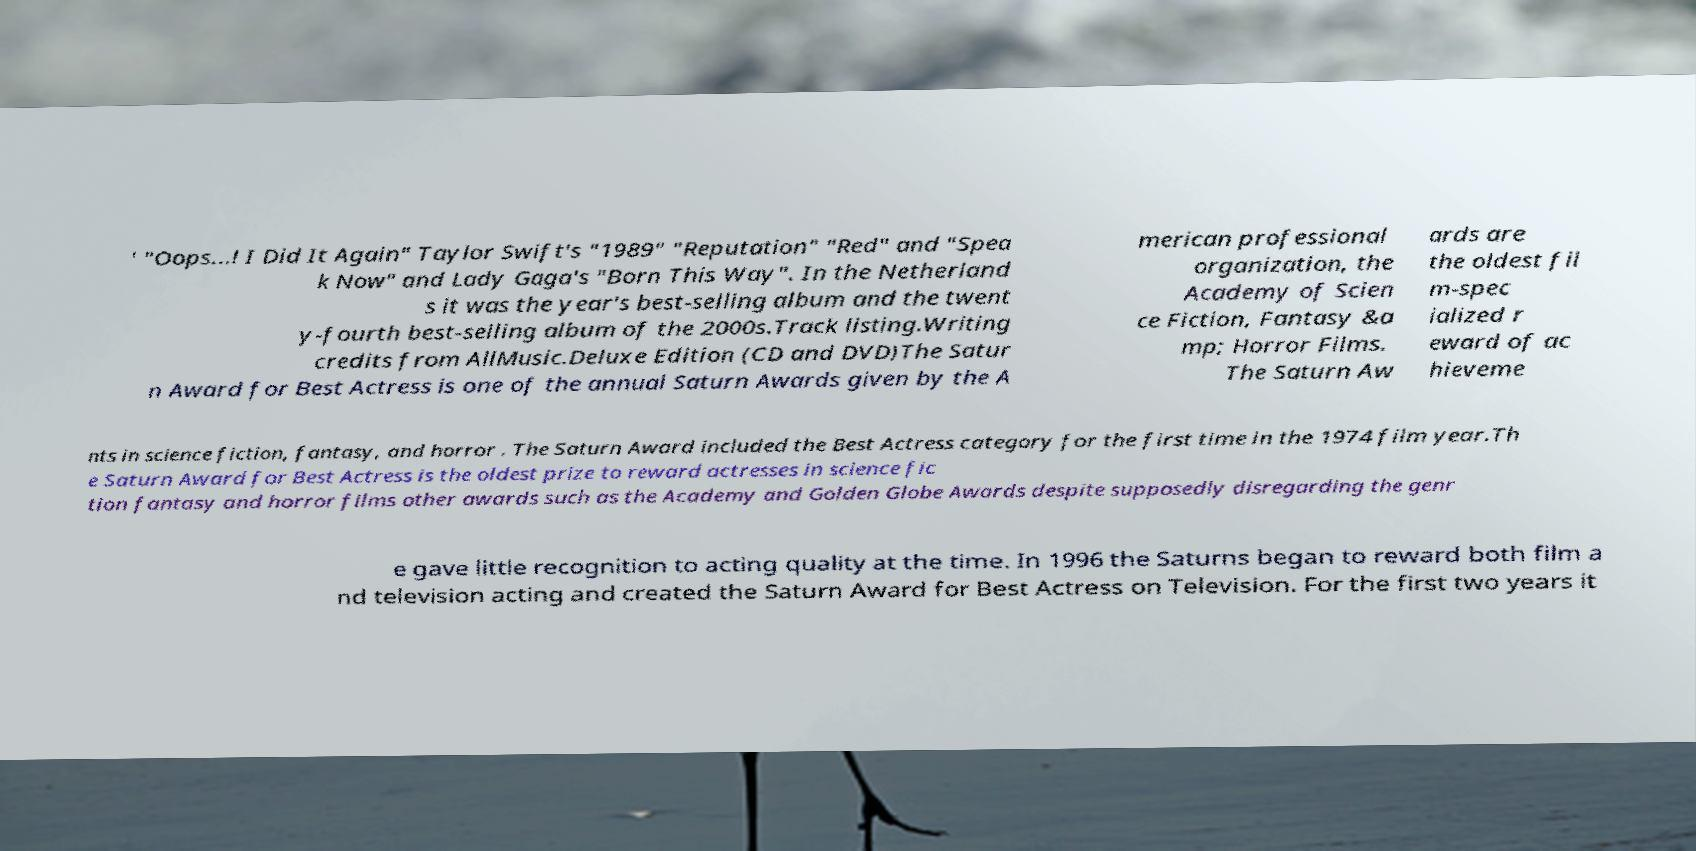For documentation purposes, I need the text within this image transcribed. Could you provide that? ' "Oops...! I Did It Again" Taylor Swift's "1989" "Reputation" "Red" and "Spea k Now" and Lady Gaga's "Born This Way". In the Netherland s it was the year's best-selling album and the twent y-fourth best-selling album of the 2000s.Track listing.Writing credits from AllMusic.Deluxe Edition (CD and DVD)The Satur n Award for Best Actress is one of the annual Saturn Awards given by the A merican professional organization, the Academy of Scien ce Fiction, Fantasy &a mp; Horror Films. The Saturn Aw ards are the oldest fil m-spec ialized r eward of ac hieveme nts in science fiction, fantasy, and horror . The Saturn Award included the Best Actress category for the first time in the 1974 film year.Th e Saturn Award for Best Actress is the oldest prize to reward actresses in science fic tion fantasy and horror films other awards such as the Academy and Golden Globe Awards despite supposedly disregarding the genr e gave little recognition to acting quality at the time. In 1996 the Saturns began to reward both film a nd television acting and created the Saturn Award for Best Actress on Television. For the first two years it 